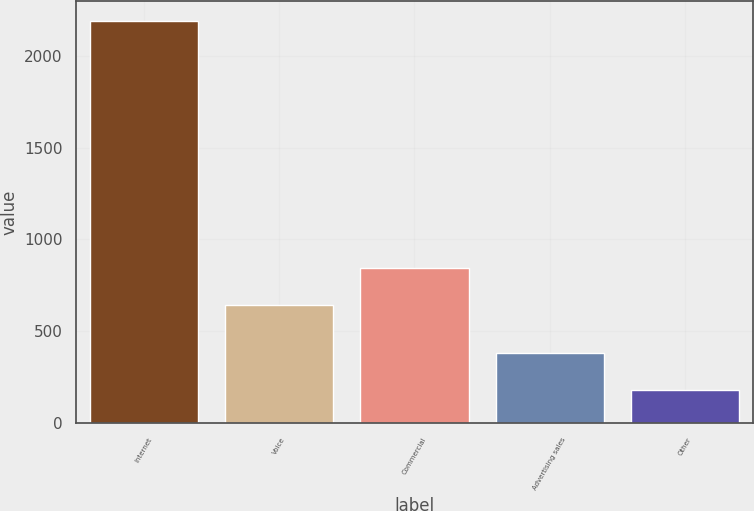Convert chart. <chart><loc_0><loc_0><loc_500><loc_500><bar_chart><fcel>Internet<fcel>Voice<fcel>Commercial<fcel>Advertising sales<fcel>Other<nl><fcel>2186<fcel>644<fcel>844.4<fcel>382.4<fcel>182<nl></chart> 